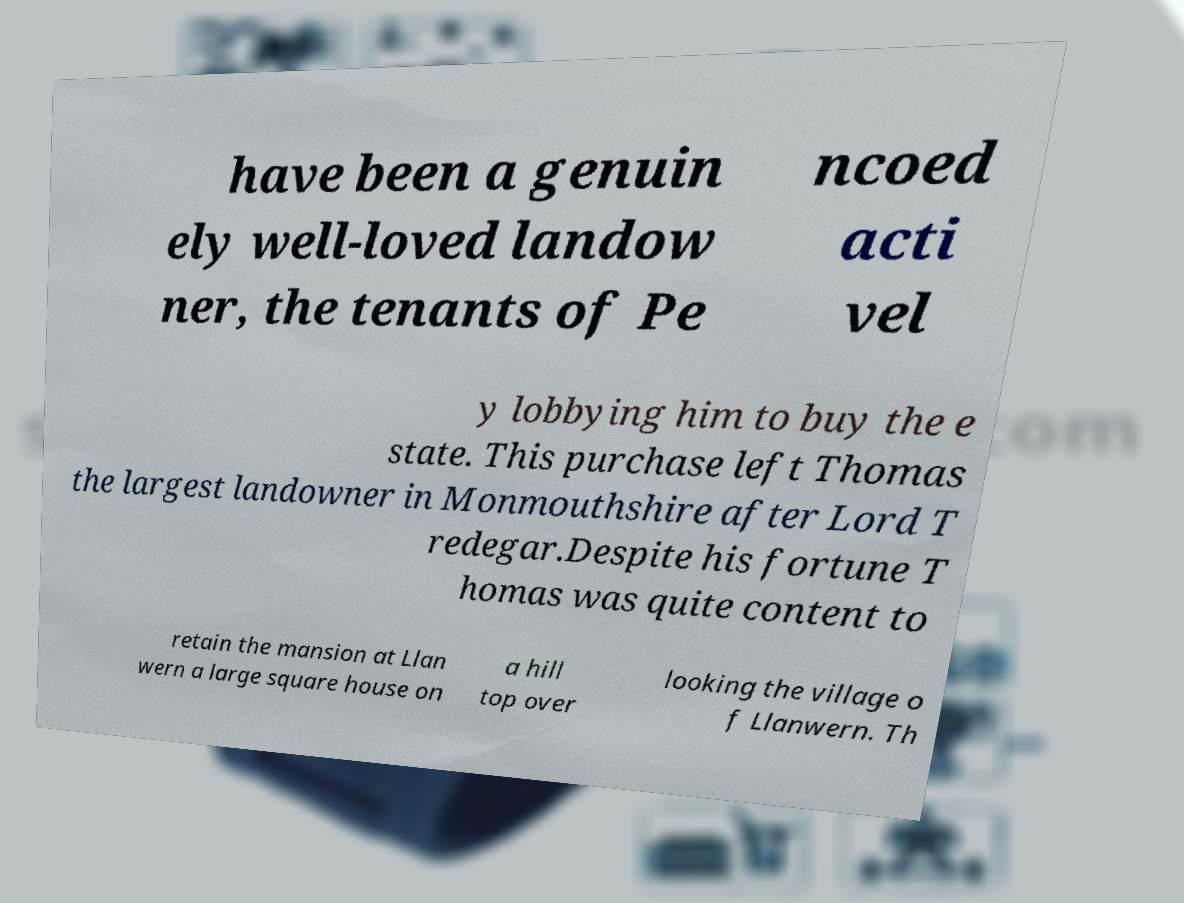Please read and relay the text visible in this image. What does it say? have been a genuin ely well-loved landow ner, the tenants of Pe ncoed acti vel y lobbying him to buy the e state. This purchase left Thomas the largest landowner in Monmouthshire after Lord T redegar.Despite his fortune T homas was quite content to retain the mansion at Llan wern a large square house on a hill top over looking the village o f Llanwern. Th 